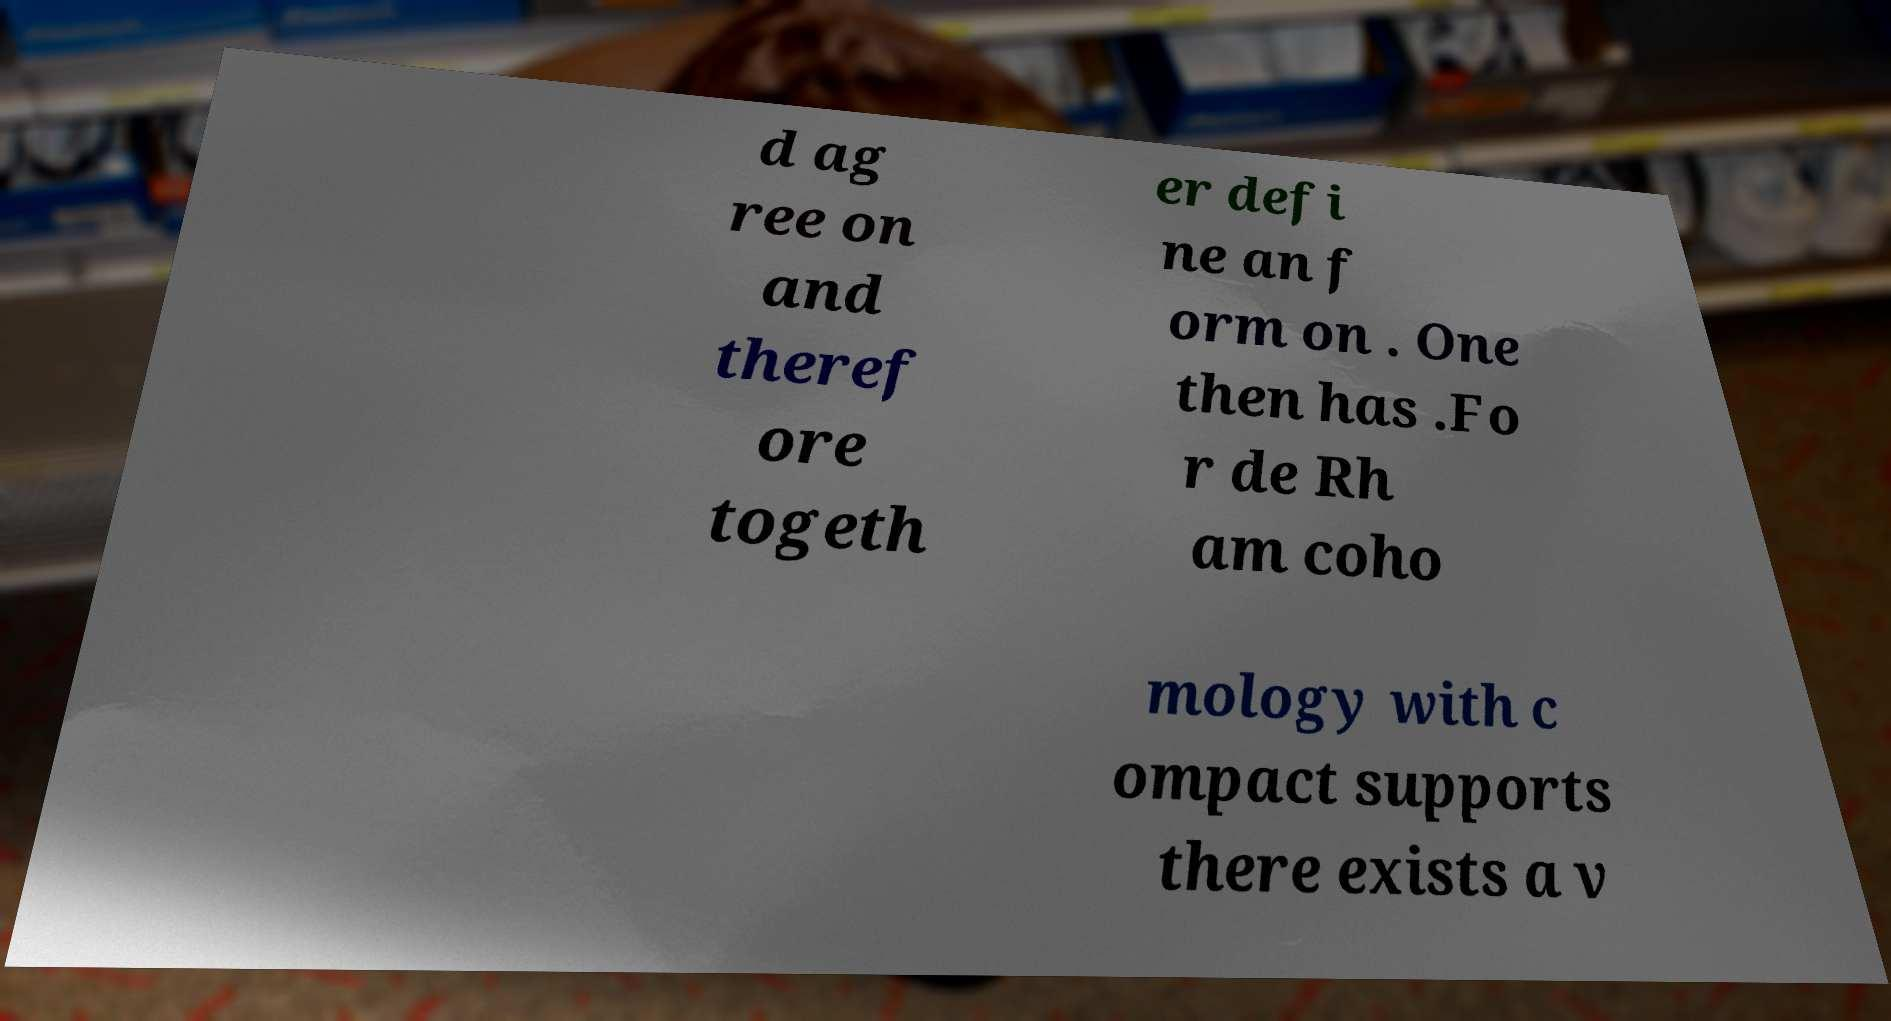Can you read and provide the text displayed in the image?This photo seems to have some interesting text. Can you extract and type it out for me? d ag ree on and theref ore togeth er defi ne an f orm on . One then has .Fo r de Rh am coho mology with c ompact supports there exists a v 